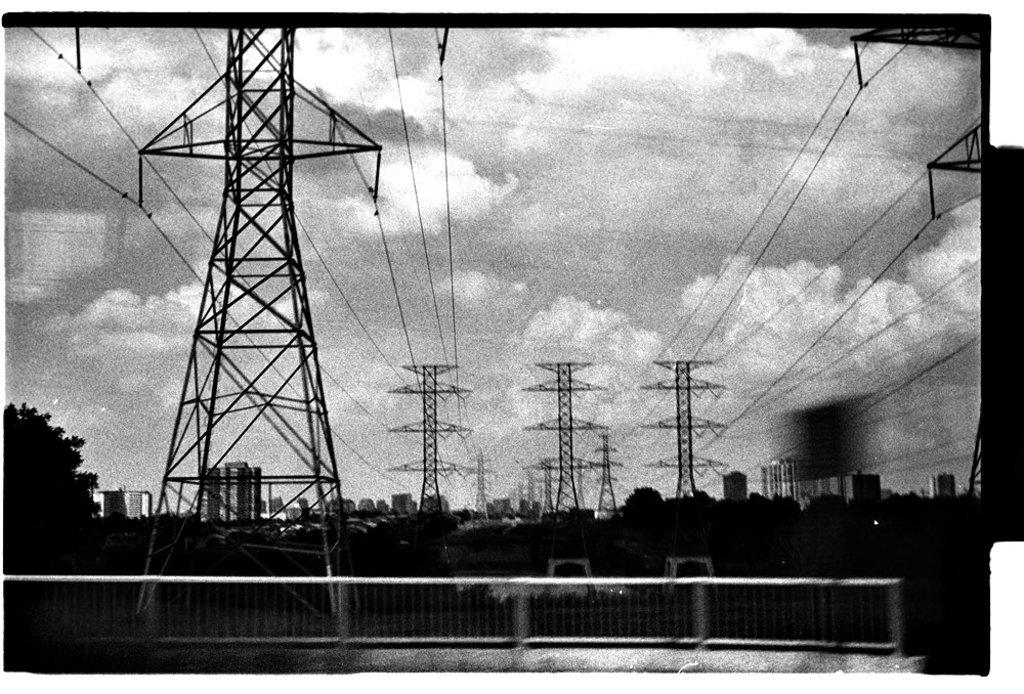What is the color scheme of the image? The image is black and white. What structures can be seen in the image? There are towers with wires in the image. What type of vegetation is present in the image? There are trees in the image. What can be seen in the background of the image? There are buildings and the sky visible in the background of the image. What is the condition of the sky in the image? Clouds are present in the sky. Can you tell me how many squirrels are climbing the trees in the image? There are no squirrels present in the image; it only features towers with wires, trees, buildings, and a sky with clouds. What page is the image taken from? The image is not taken from a page, as it is a standalone photograph. 